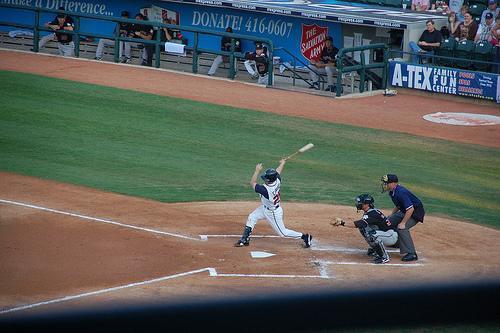How many people are on the field?
Give a very brief answer. 3. 